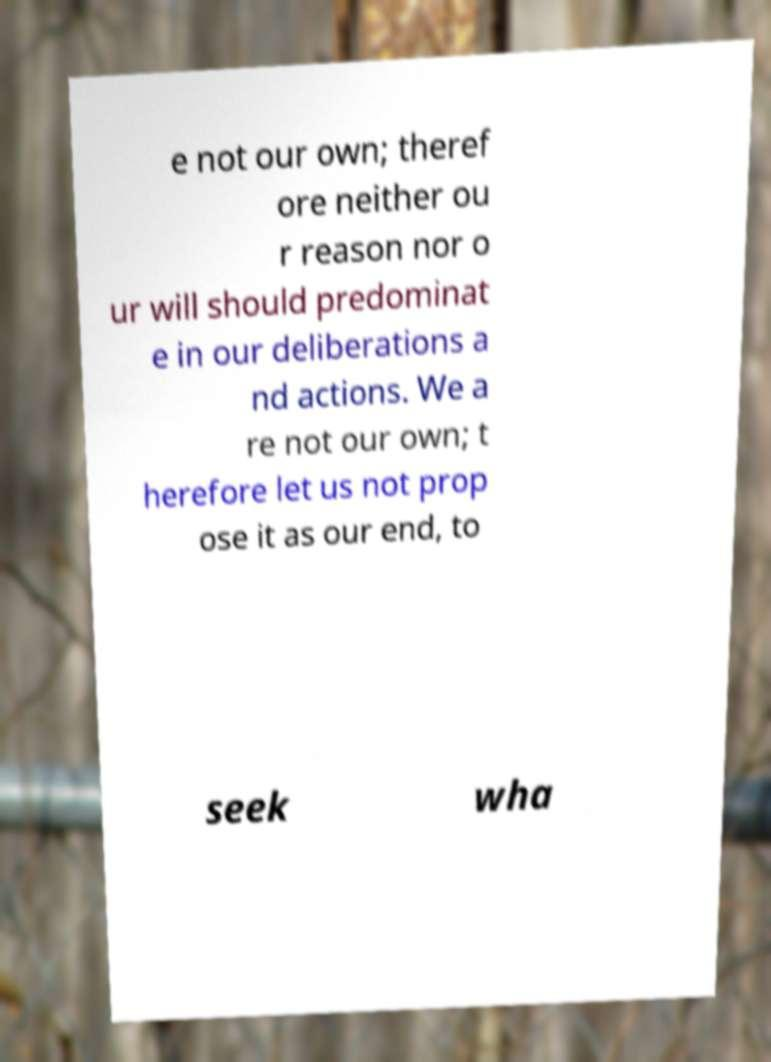Could you assist in decoding the text presented in this image and type it out clearly? e not our own; theref ore neither ou r reason nor o ur will should predominat e in our deliberations a nd actions. We a re not our own; t herefore let us not prop ose it as our end, to seek wha 